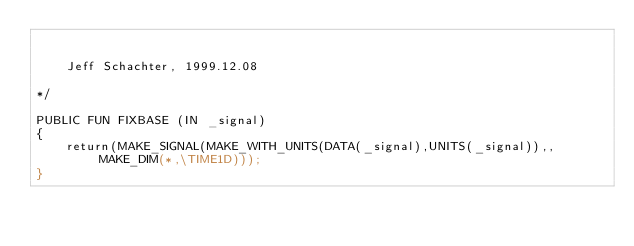<code> <loc_0><loc_0><loc_500><loc_500><_SML_>

	Jeff Schachter, 1999.12.08

*/

PUBLIC FUN FIXBASE (IN _signal)
{
	return(MAKE_SIGNAL(MAKE_WITH_UNITS(DATA(_signal),UNITS(_signal)),,MAKE_DIM(*,\TIME1D)));
}
	

</code> 